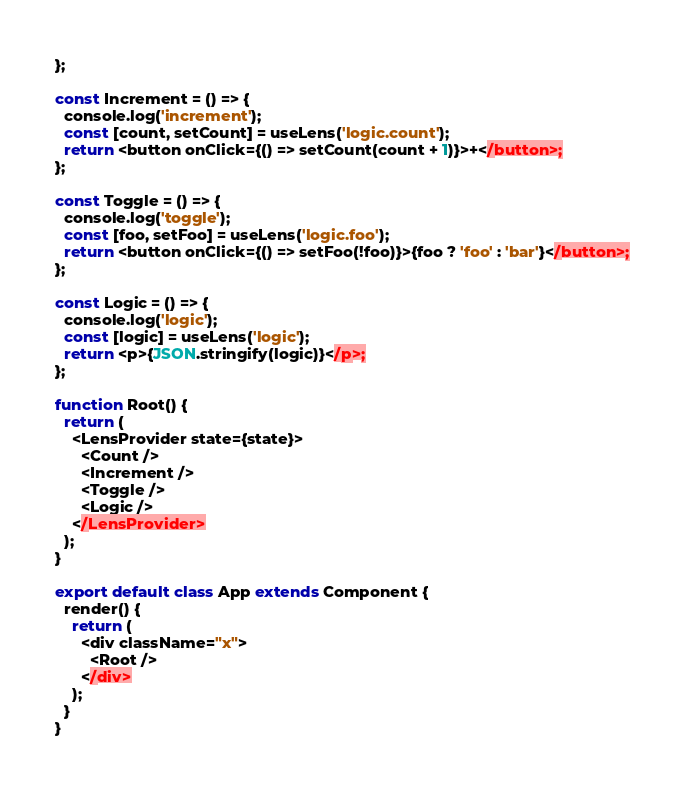<code> <loc_0><loc_0><loc_500><loc_500><_JavaScript_>};

const Increment = () => {
  console.log('increment');
  const [count, setCount] = useLens('logic.count');
  return <button onClick={() => setCount(count + 1)}>+</button>;
};

const Toggle = () => {
  console.log('toggle');
  const [foo, setFoo] = useLens('logic.foo');
  return <button onClick={() => setFoo(!foo)}>{foo ? 'foo' : 'bar'}</button>;
};

const Logic = () => {
  console.log('logic');
  const [logic] = useLens('logic');
  return <p>{JSON.stringify(logic)}</p>;
};

function Root() {
  return (
    <LensProvider state={state}>
      <Count />
      <Increment />
      <Toggle />
      <Logic />
    </LensProvider>
  );
}

export default class App extends Component {
  render() {
    return (
      <div className="x">
        <Root />
      </div>
    );
  }
}
</code> 